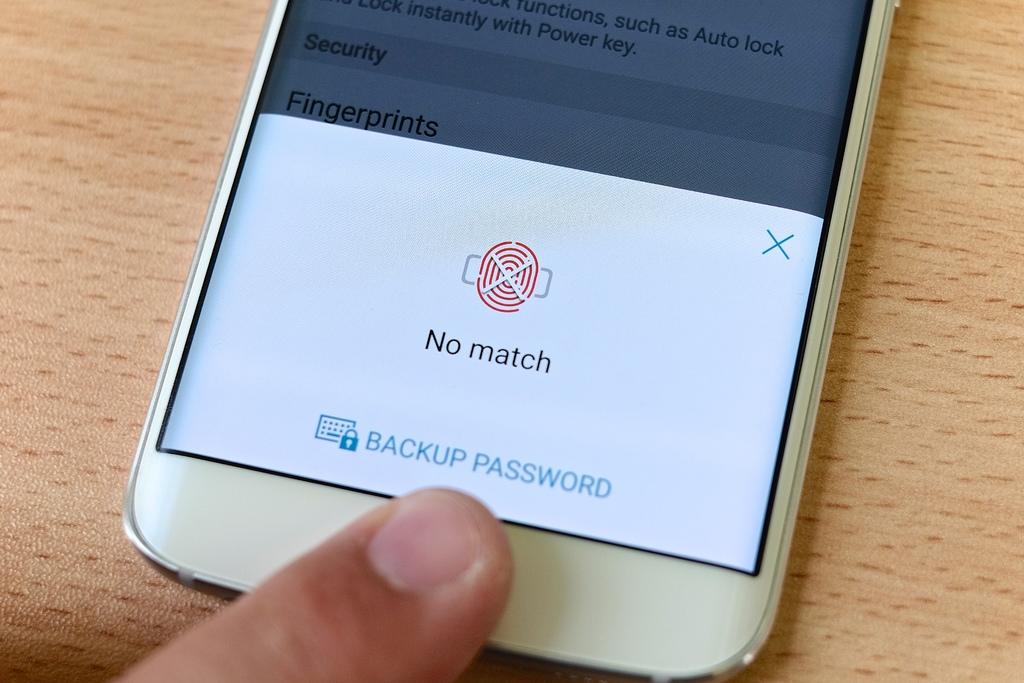Does the fingerprint match or not?
Provide a short and direct response. No. 